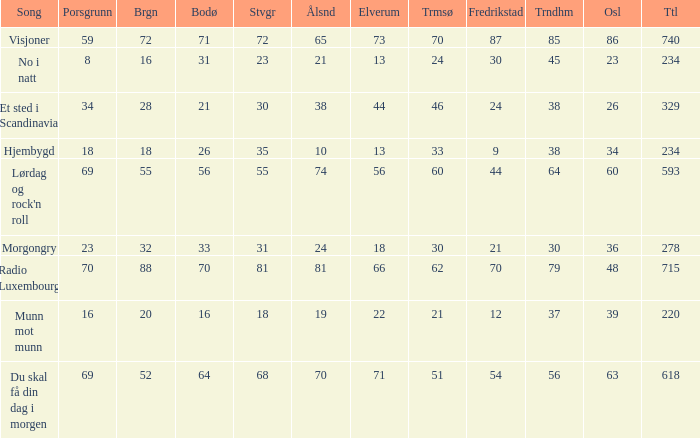What is the lowest total? 220.0. 